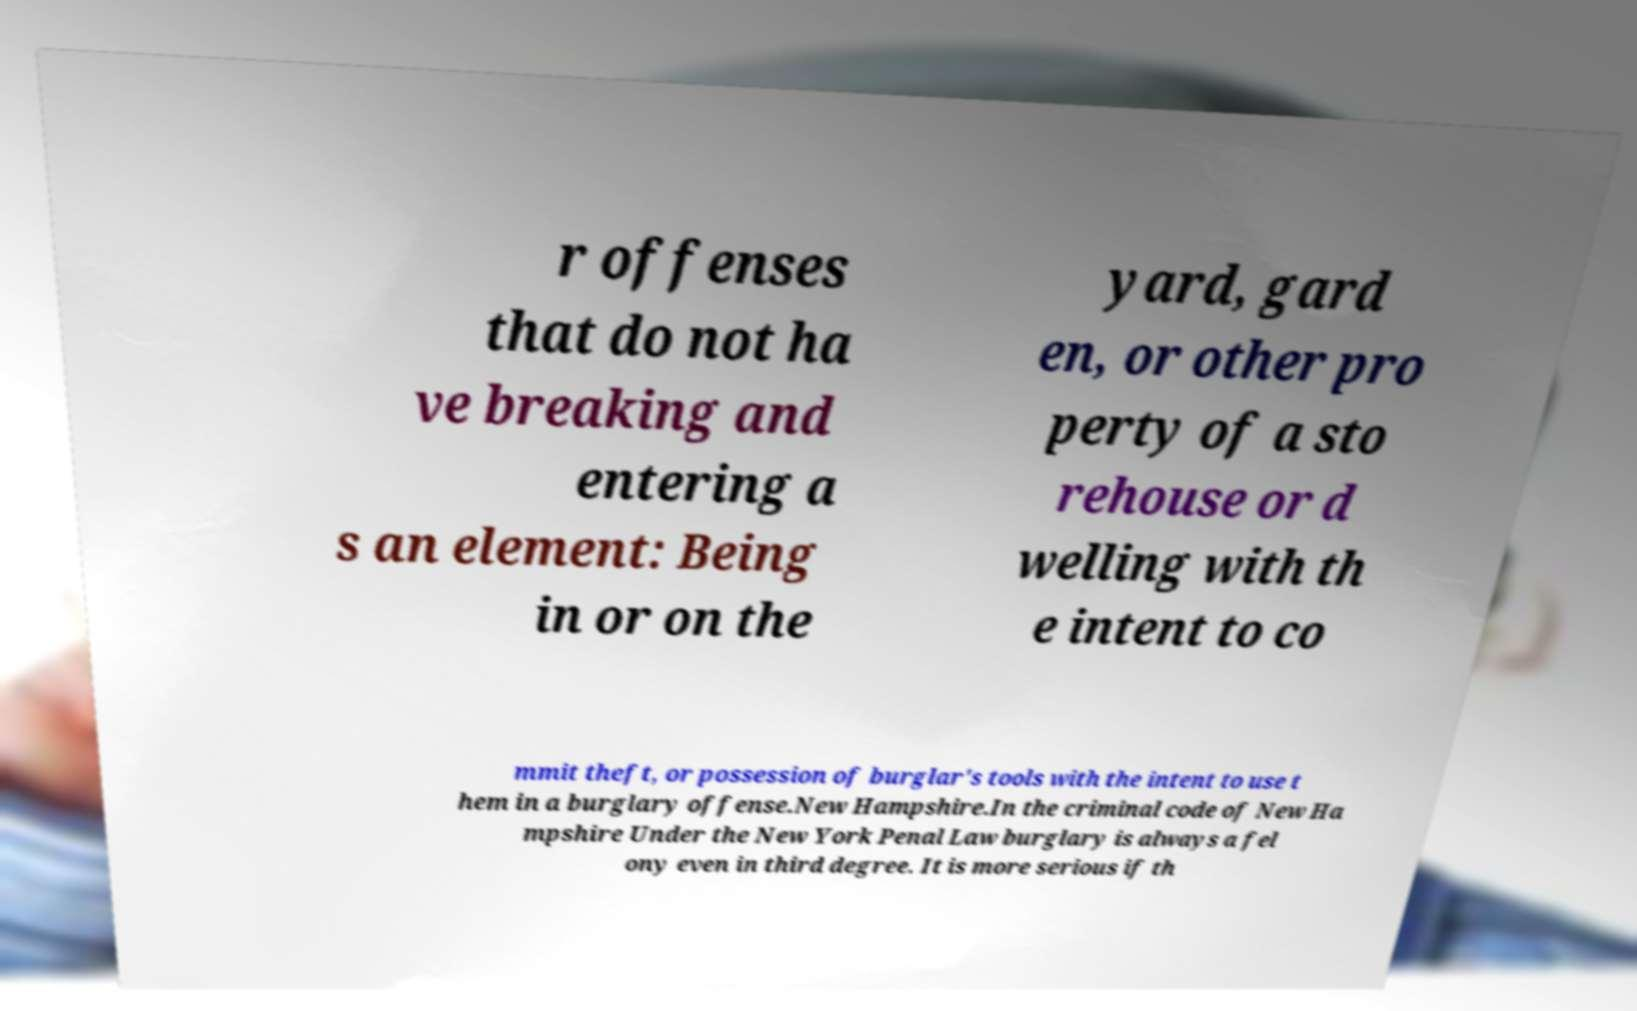Can you read and provide the text displayed in the image?This photo seems to have some interesting text. Can you extract and type it out for me? r offenses that do not ha ve breaking and entering a s an element: Being in or on the yard, gard en, or other pro perty of a sto rehouse or d welling with th e intent to co mmit theft, or possession of burglar's tools with the intent to use t hem in a burglary offense.New Hampshire.In the criminal code of New Ha mpshire Under the New York Penal Law burglary is always a fel ony even in third degree. It is more serious if th 